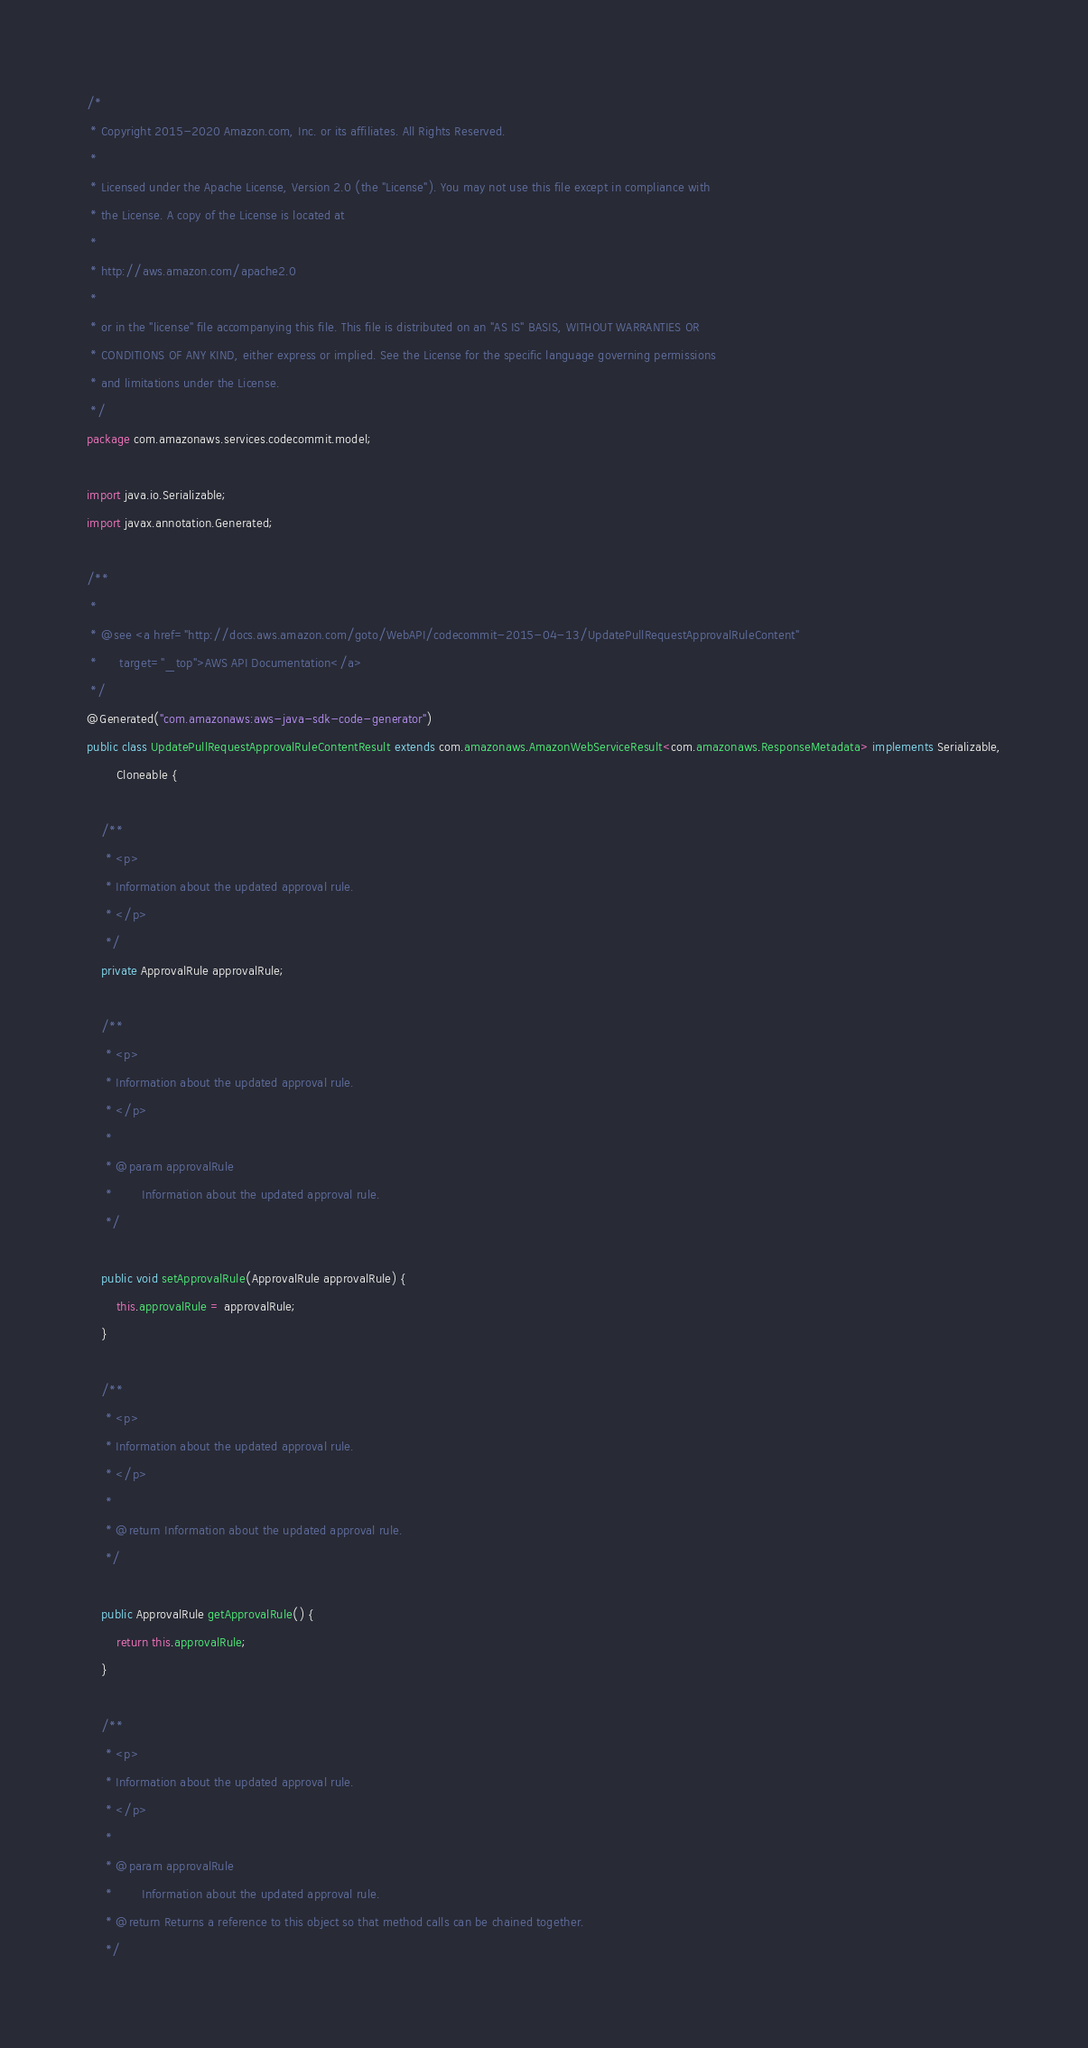Convert code to text. <code><loc_0><loc_0><loc_500><loc_500><_Java_>/*
 * Copyright 2015-2020 Amazon.com, Inc. or its affiliates. All Rights Reserved.
 * 
 * Licensed under the Apache License, Version 2.0 (the "License"). You may not use this file except in compliance with
 * the License. A copy of the License is located at
 * 
 * http://aws.amazon.com/apache2.0
 * 
 * or in the "license" file accompanying this file. This file is distributed on an "AS IS" BASIS, WITHOUT WARRANTIES OR
 * CONDITIONS OF ANY KIND, either express or implied. See the License for the specific language governing permissions
 * and limitations under the License.
 */
package com.amazonaws.services.codecommit.model;

import java.io.Serializable;
import javax.annotation.Generated;

/**
 * 
 * @see <a href="http://docs.aws.amazon.com/goto/WebAPI/codecommit-2015-04-13/UpdatePullRequestApprovalRuleContent"
 *      target="_top">AWS API Documentation</a>
 */
@Generated("com.amazonaws:aws-java-sdk-code-generator")
public class UpdatePullRequestApprovalRuleContentResult extends com.amazonaws.AmazonWebServiceResult<com.amazonaws.ResponseMetadata> implements Serializable,
        Cloneable {

    /**
     * <p>
     * Information about the updated approval rule.
     * </p>
     */
    private ApprovalRule approvalRule;

    /**
     * <p>
     * Information about the updated approval rule.
     * </p>
     * 
     * @param approvalRule
     *        Information about the updated approval rule.
     */

    public void setApprovalRule(ApprovalRule approvalRule) {
        this.approvalRule = approvalRule;
    }

    /**
     * <p>
     * Information about the updated approval rule.
     * </p>
     * 
     * @return Information about the updated approval rule.
     */

    public ApprovalRule getApprovalRule() {
        return this.approvalRule;
    }

    /**
     * <p>
     * Information about the updated approval rule.
     * </p>
     * 
     * @param approvalRule
     *        Information about the updated approval rule.
     * @return Returns a reference to this object so that method calls can be chained together.
     */
</code> 